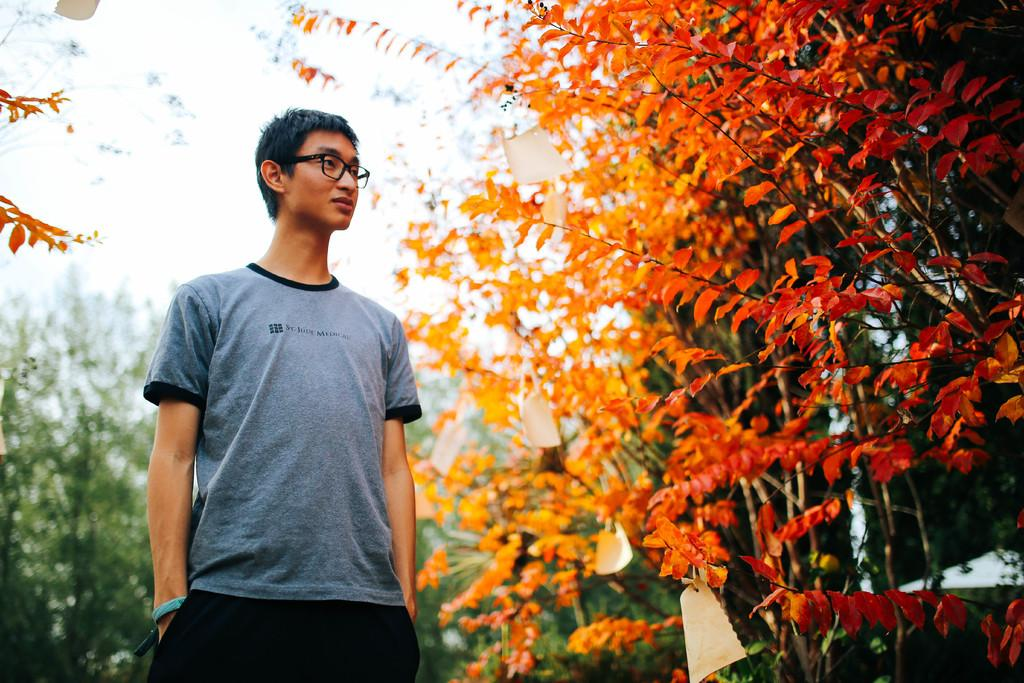What is the position of the man in the image? The man is standing on the left side of the image. What is the man wearing on his upper body? The man is wearing a t-shirt. What type of eyewear is the man wearing? The man is wearing black color spectacles. What can be seen on the right side of the image? There are plants on the right side of the image. What direction is the governor facing in the image? There is no governor present in the image. 